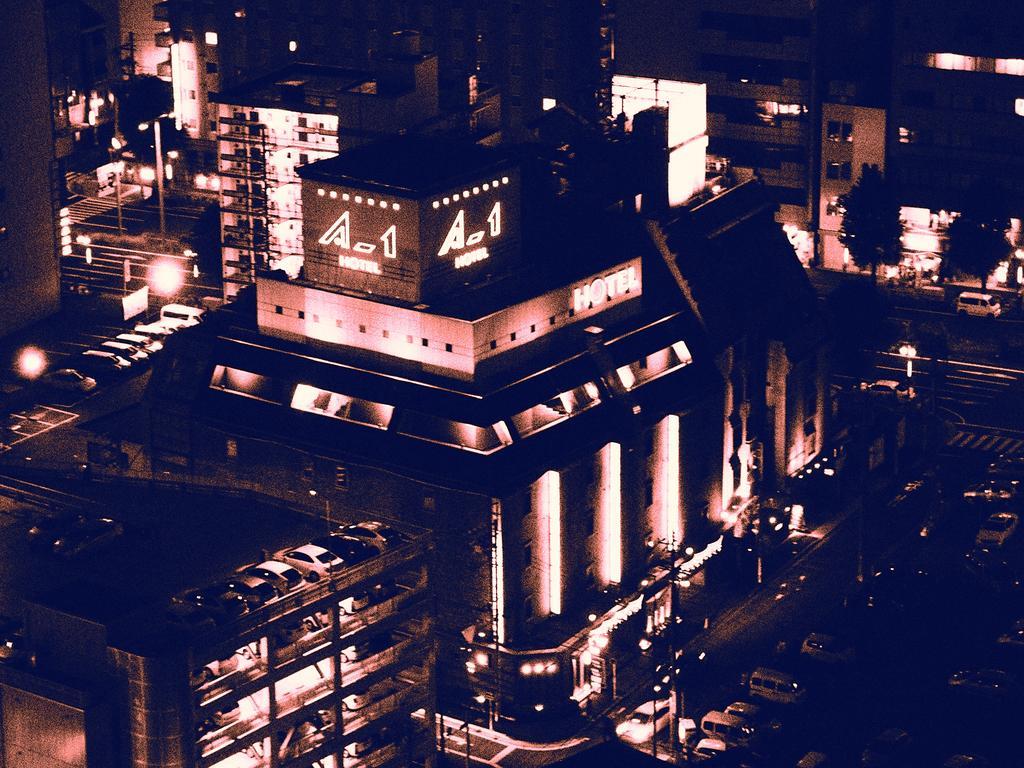Please provide a concise description of this image. In this image we can see many buildings around. And at the bottom right hand corner we can see many vehicles on the road. 